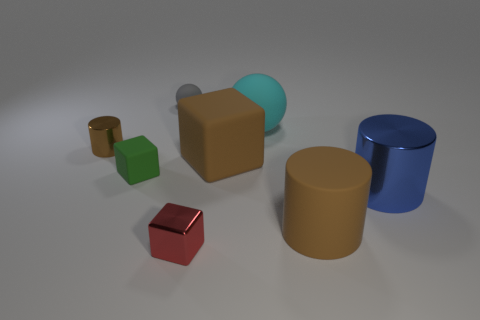Add 2 tiny matte spheres. How many objects exist? 10 Subtract all spheres. How many objects are left? 6 Subtract 0 purple balls. How many objects are left? 8 Subtract all big matte cubes. Subtract all small brown cylinders. How many objects are left? 6 Add 3 large metallic things. How many large metallic things are left? 4 Add 8 small green things. How many small green things exist? 9 